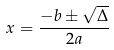<formula> <loc_0><loc_0><loc_500><loc_500>x = \frac { - b \pm \sqrt { \Delta } } { 2 a }</formula> 